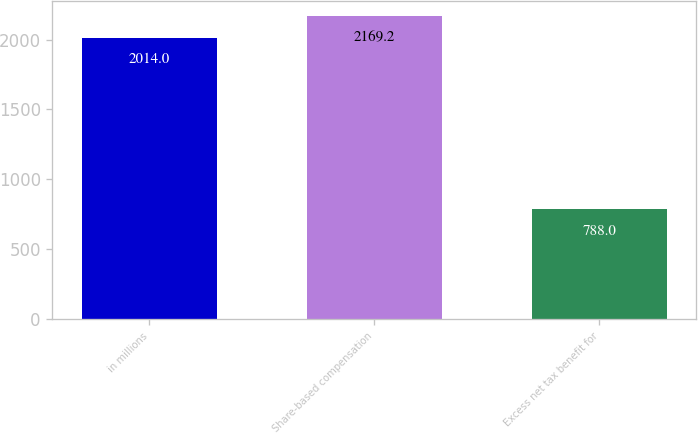<chart> <loc_0><loc_0><loc_500><loc_500><bar_chart><fcel>in millions<fcel>Share-based compensation<fcel>Excess net tax benefit for<nl><fcel>2014<fcel>2169.2<fcel>788<nl></chart> 